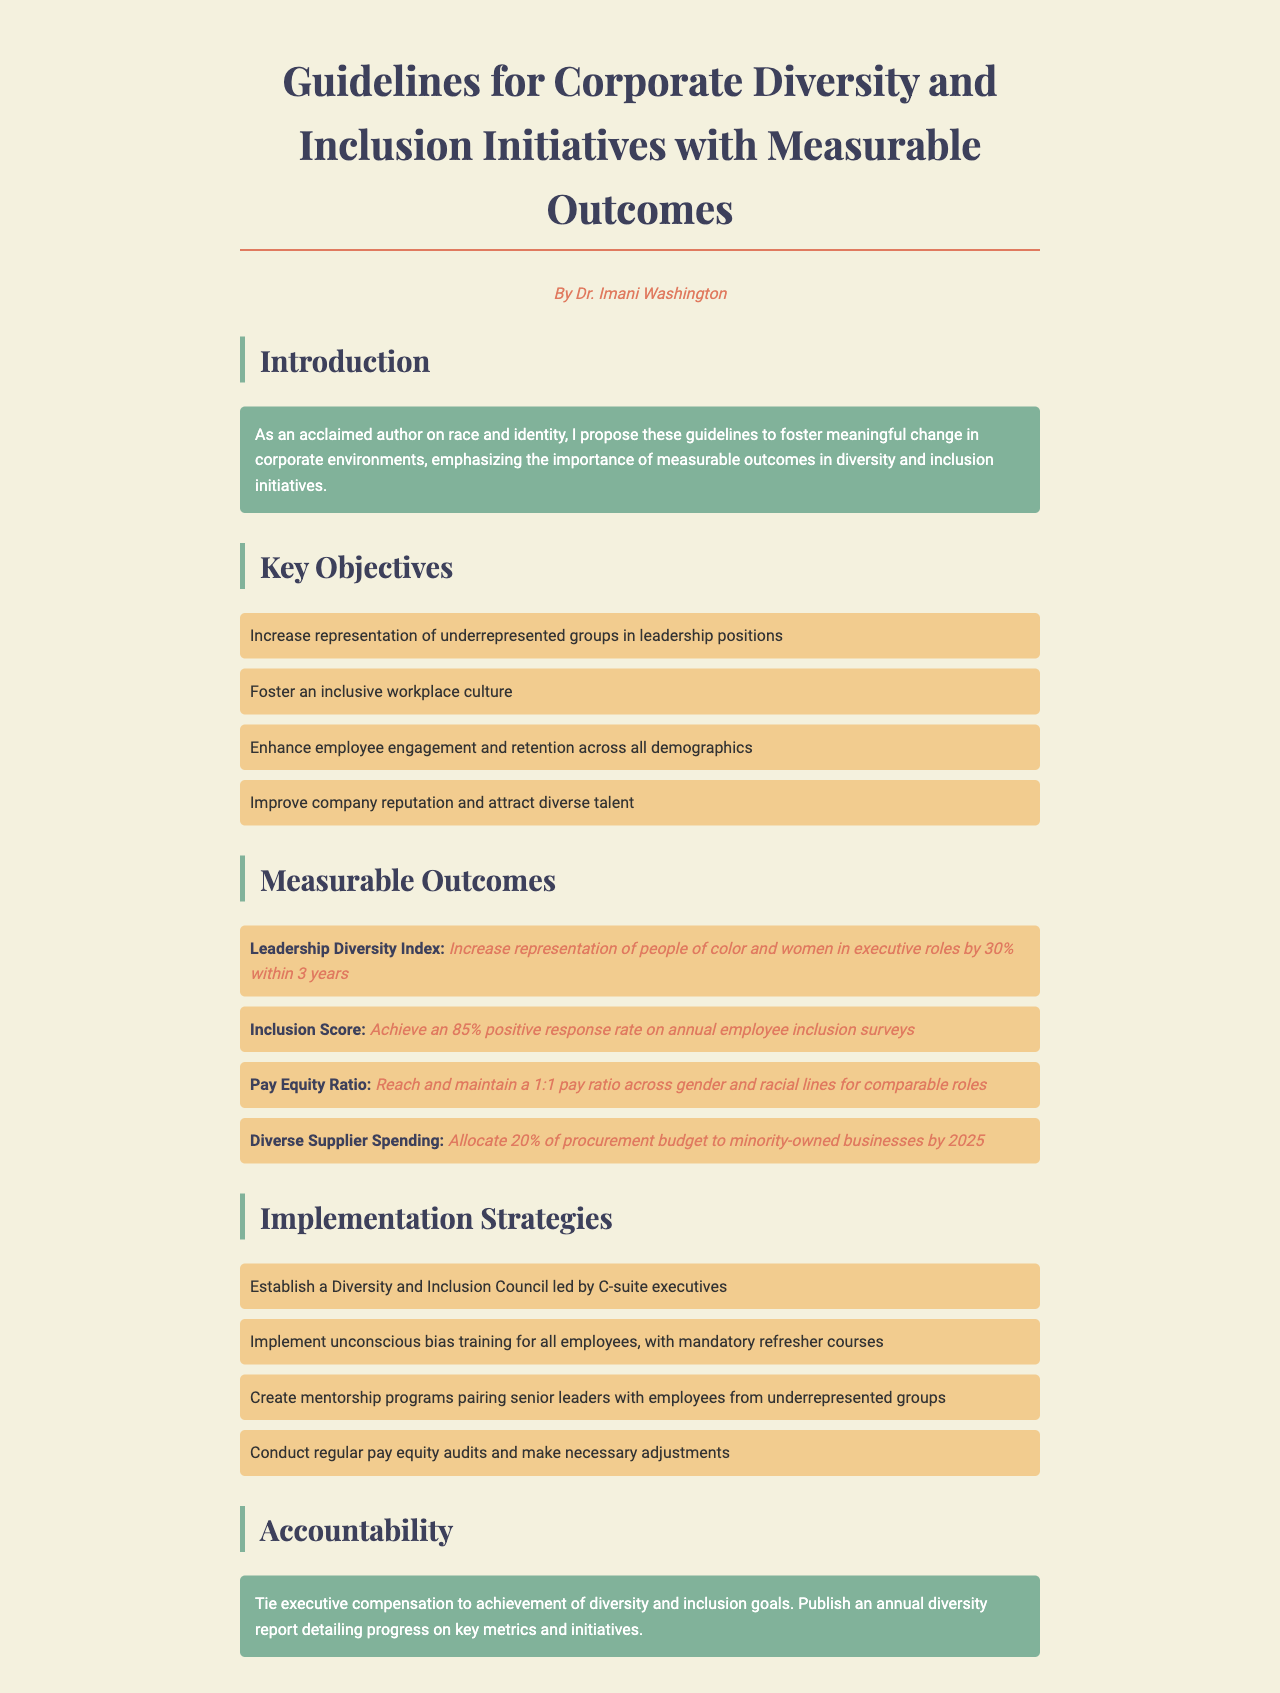What is the title of the document? The title is presented at the top of the document under a prominent heading.
Answer: Guidelines for Corporate Diversity and Inclusion Initiatives with Measurable Outcomes Who authored the document? The author is mentioned below the title, providing credibility to the document.
Answer: Dr. Imani Washington What is the target percentage increase in leadership position diversity? The specific target regarding leadership positions is stated clearly in the measurable outcomes section.
Answer: 30% What is the desired positive response rate for the Inclusion Score? The document specifies a target response rate related to annual employee inclusion surveys.
Answer: 85% What is the diversity spending goal for minority-owned businesses by 2025? This information details the allocation of procurement budgets as part of measurable outcomes.
Answer: 20% What is one of the implementation strategies mentioned? The document outlines strategies for promoting diversity and inclusion initiatives, indicating specific actions to be taken.
Answer: Unconscious bias training How often should pay equity audits be conducted? This information is found in the implementation strategies section, addressing regular reviews.
Answer: Regularly What is tied to executive compensation according to the accountability section? The accountability measures clarify the importance of linking executive incentives to specific metrics.
Answer: Diversity and inclusion goals 